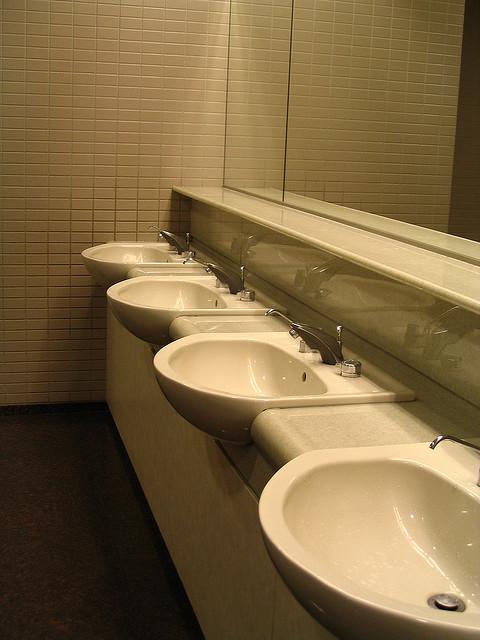What is the back wall made of?
Write a very short answer. Tile. When was this taken?
Keep it brief. Bathroom. How many sinks are here?
Keep it brief. 4. 